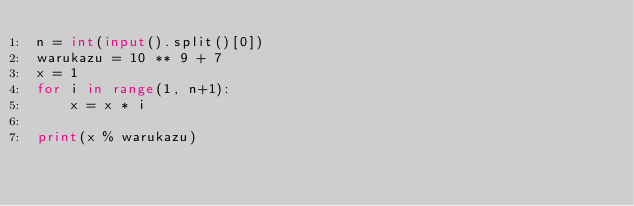Convert code to text. <code><loc_0><loc_0><loc_500><loc_500><_Python_>n = int(input().split()[0])
warukazu = 10 ** 9 + 7
x = 1
for i in range(1, n+1):
    x = x * i

print(x % warukazu)</code> 